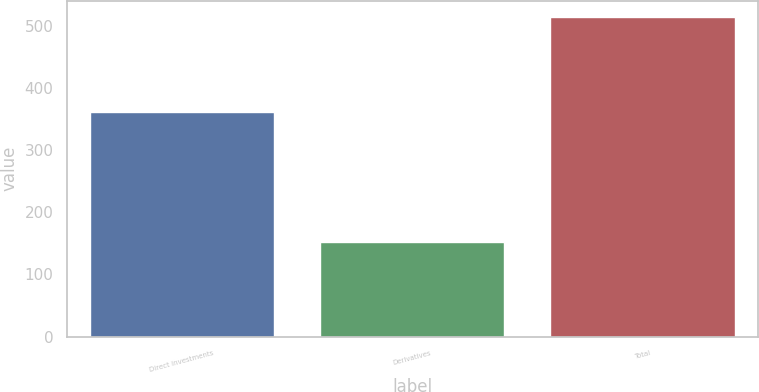Convert chart. <chart><loc_0><loc_0><loc_500><loc_500><bar_chart><fcel>Direct investments<fcel>Derivatives<fcel>Total<nl><fcel>362<fcel>153<fcel>515<nl></chart> 